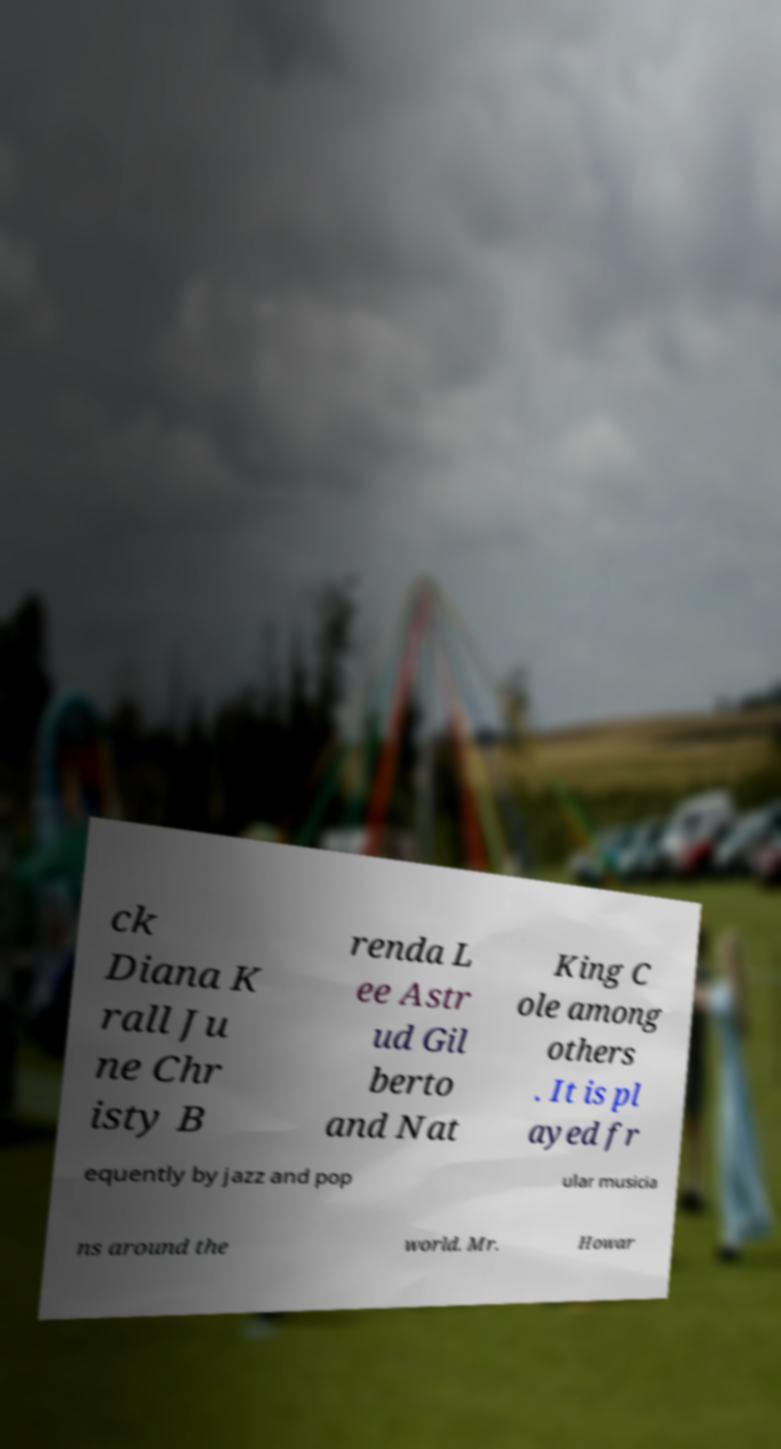What messages or text are displayed in this image? I need them in a readable, typed format. ck Diana K rall Ju ne Chr isty B renda L ee Astr ud Gil berto and Nat King C ole among others . It is pl ayed fr equently by jazz and pop ular musicia ns around the world. Mr. Howar 